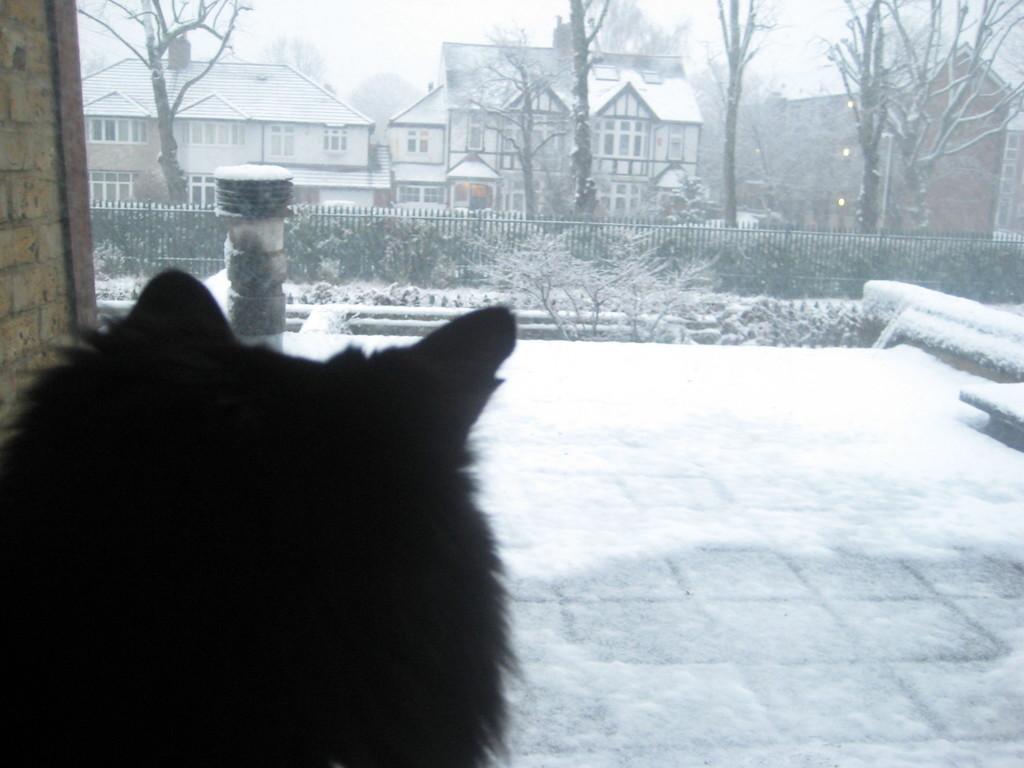How would you summarize this image in a sentence or two? In this image we can see an animal. In the back there are trees, buildings with windows. Also there is railing. And there is snow everywhere. 